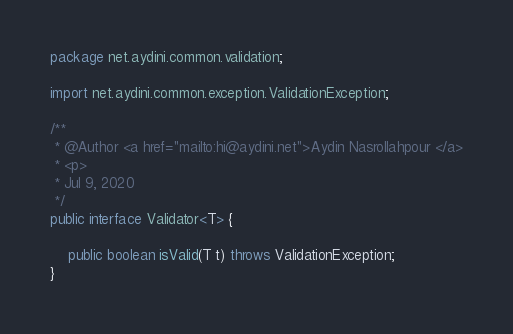<code> <loc_0><loc_0><loc_500><loc_500><_Java_>package net.aydini.common.validation;

import net.aydini.common.exception.ValidationException;

/**
 * @Author <a href="mailto:hi@aydini.net">Aydin Nasrollahpour </a>
 * <p>
 * Jul 9, 2020
 */
public interface Validator<T> {

    public boolean isValid(T t) throws ValidationException;
}
</code> 